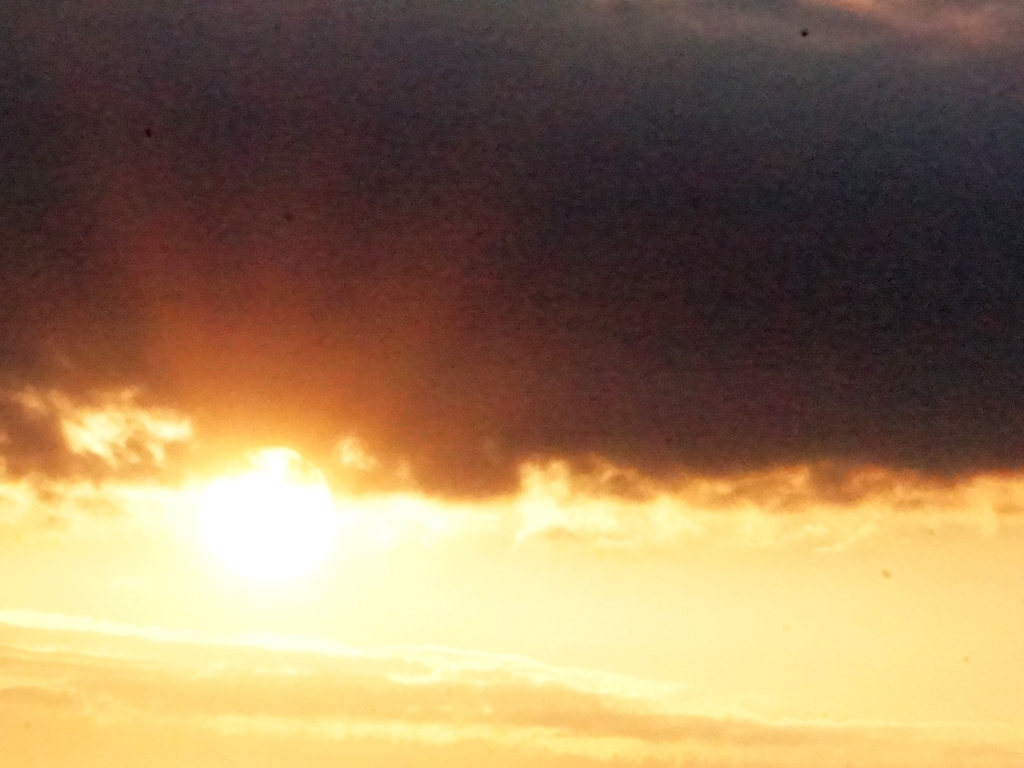How might the weather change after this moment? Judging by the dark cloud and the lighting's warm tones, it's possible that the weather might clear up if it's sunrise, or it could signify an approaching evening storm if it's sunset. 